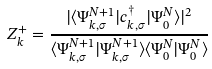<formula> <loc_0><loc_0><loc_500><loc_500>Z _ { k } ^ { + } = \frac { | \langle \Psi _ { k , \sigma } ^ { N + 1 } | c _ { k , \sigma } ^ { \dagger } | \Psi _ { 0 } ^ { N } \rangle | ^ { 2 } } { \langle \Psi _ { k , \sigma } ^ { N + 1 } | \Psi _ { k , \sigma } ^ { N + 1 } \rangle \langle \Psi _ { 0 } ^ { N } | \Psi _ { 0 } ^ { N } \rangle }</formula> 